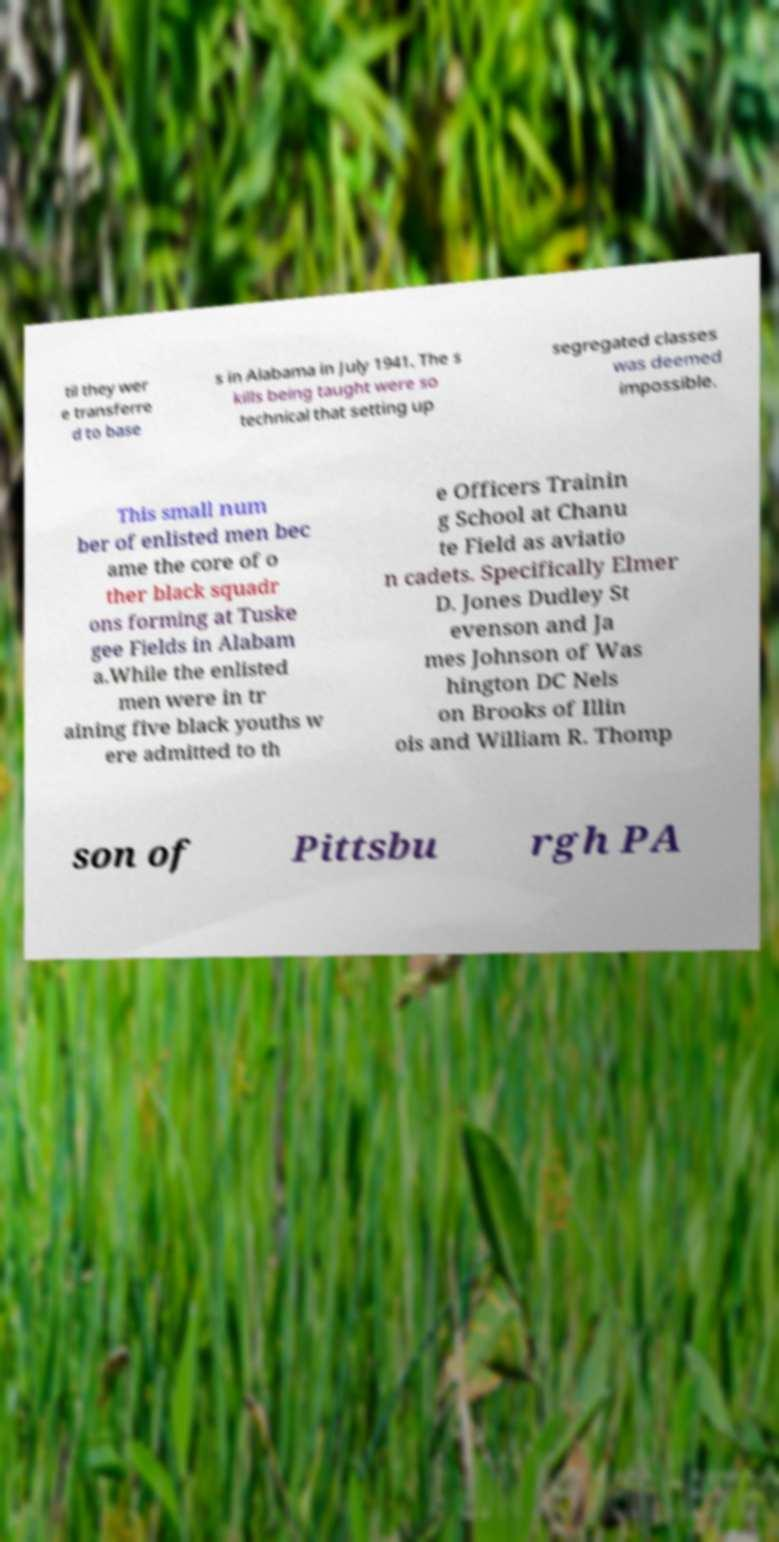There's text embedded in this image that I need extracted. Can you transcribe it verbatim? til they wer e transferre d to base s in Alabama in July 1941. The s kills being taught were so technical that setting up segregated classes was deemed impossible. This small num ber of enlisted men bec ame the core of o ther black squadr ons forming at Tuske gee Fields in Alabam a.While the enlisted men were in tr aining five black youths w ere admitted to th e Officers Trainin g School at Chanu te Field as aviatio n cadets. Specifically Elmer D. Jones Dudley St evenson and Ja mes Johnson of Was hington DC Nels on Brooks of Illin ois and William R. Thomp son of Pittsbu rgh PA 